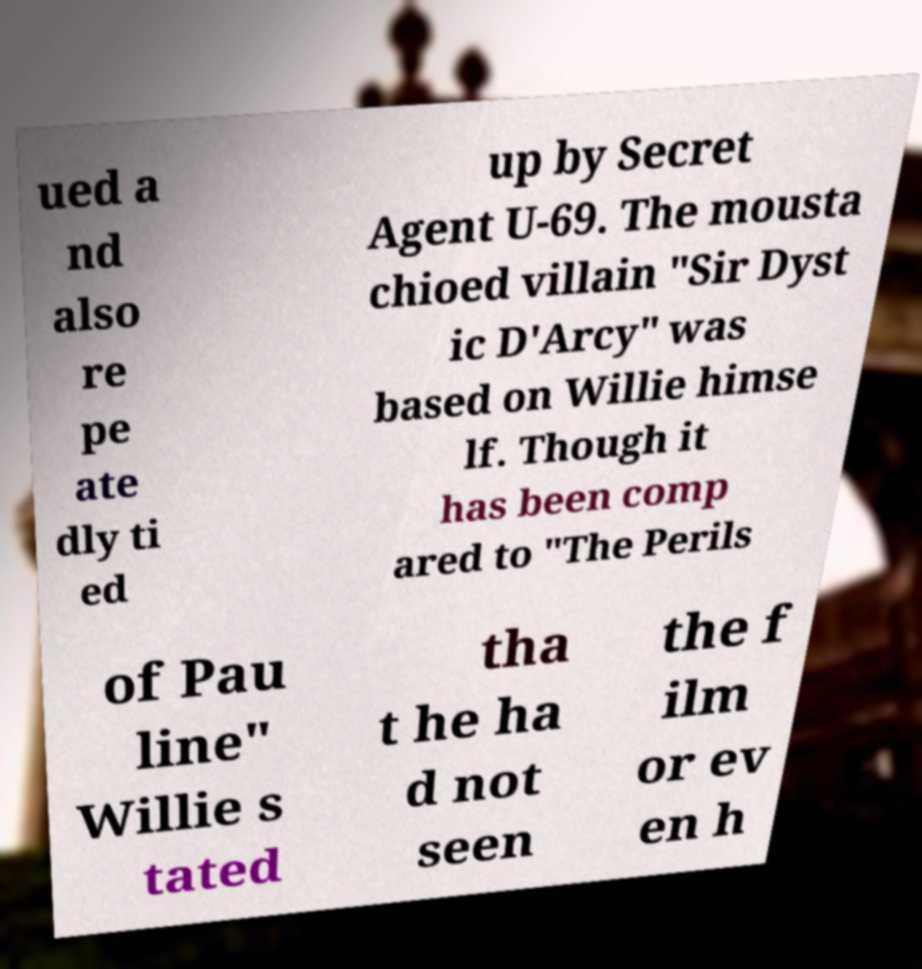Please read and relay the text visible in this image. What does it say? ued a nd also re pe ate dly ti ed up by Secret Agent U-69. The mousta chioed villain "Sir Dyst ic D'Arcy" was based on Willie himse lf. Though it has been comp ared to "The Perils of Pau line" Willie s tated tha t he ha d not seen the f ilm or ev en h 